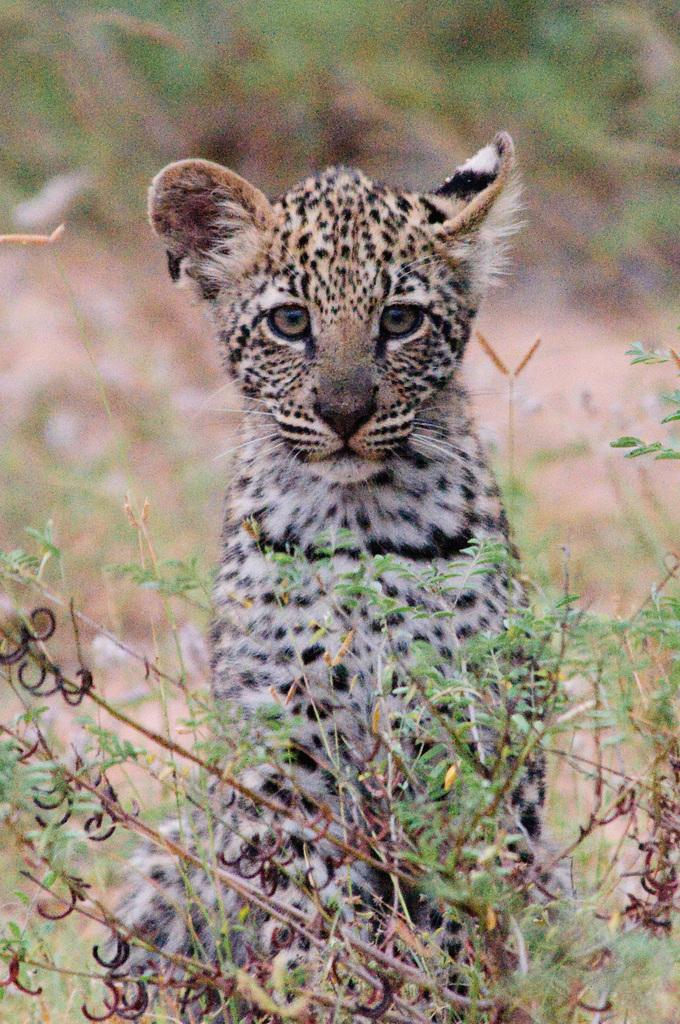What type of animal is in the image? There is a leopard cub in the image. What else can be seen in the image besides the leopard cub? There are stems with leaves in the image. Can you describe the background of the image? The background of the image is blurry. What is the mass of the sticks in the image? There are no sticks present in the image; only stems with leaves are visible. 